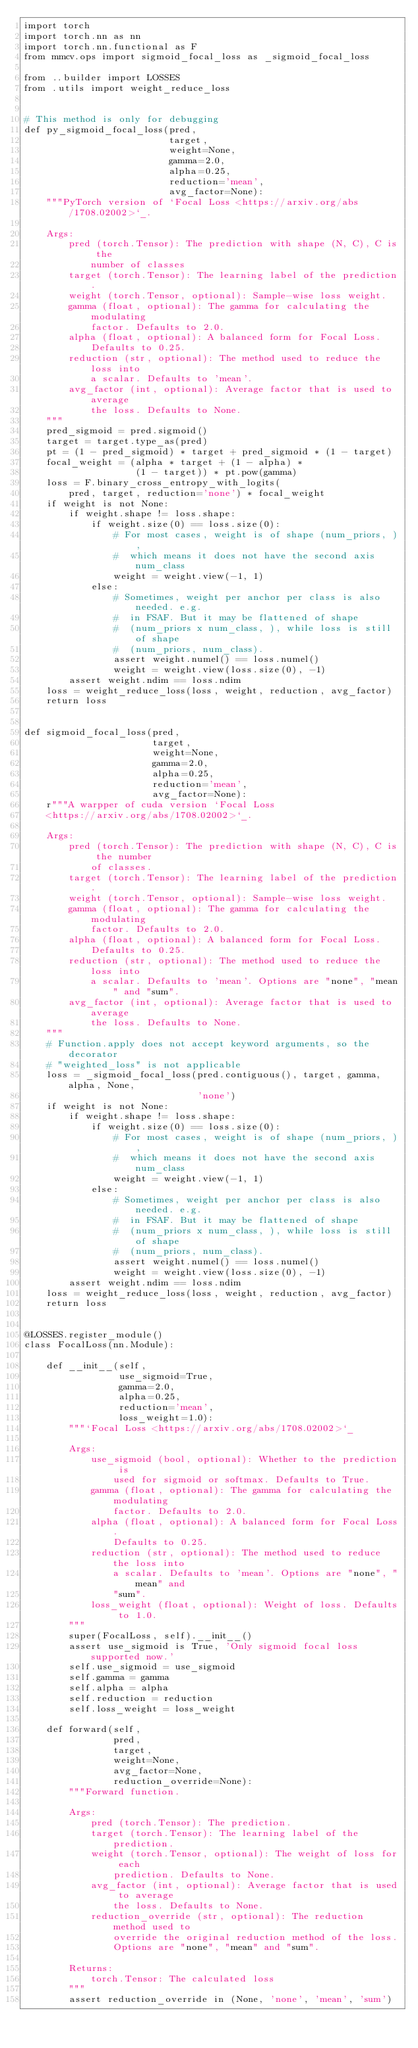<code> <loc_0><loc_0><loc_500><loc_500><_Python_>import torch
import torch.nn as nn
import torch.nn.functional as F
from mmcv.ops import sigmoid_focal_loss as _sigmoid_focal_loss

from ..builder import LOSSES
from .utils import weight_reduce_loss


# This method is only for debugging
def py_sigmoid_focal_loss(pred,
                          target,
                          weight=None,
                          gamma=2.0,
                          alpha=0.25,
                          reduction='mean',
                          avg_factor=None):
    """PyTorch version of `Focal Loss <https://arxiv.org/abs/1708.02002>`_.

    Args:
        pred (torch.Tensor): The prediction with shape (N, C), C is the
            number of classes
        target (torch.Tensor): The learning label of the prediction.
        weight (torch.Tensor, optional): Sample-wise loss weight.
        gamma (float, optional): The gamma for calculating the modulating
            factor. Defaults to 2.0.
        alpha (float, optional): A balanced form for Focal Loss.
            Defaults to 0.25.
        reduction (str, optional): The method used to reduce the loss into
            a scalar. Defaults to 'mean'.
        avg_factor (int, optional): Average factor that is used to average
            the loss. Defaults to None.
    """
    pred_sigmoid = pred.sigmoid()
    target = target.type_as(pred)
    pt = (1 - pred_sigmoid) * target + pred_sigmoid * (1 - target)
    focal_weight = (alpha * target + (1 - alpha) *
                    (1 - target)) * pt.pow(gamma)
    loss = F.binary_cross_entropy_with_logits(
        pred, target, reduction='none') * focal_weight
    if weight is not None:
        if weight.shape != loss.shape:
            if weight.size(0) == loss.size(0):
                # For most cases, weight is of shape (num_priors, ),
                #  which means it does not have the second axis num_class
                weight = weight.view(-1, 1)
            else:
                # Sometimes, weight per anchor per class is also needed. e.g.
                #  in FSAF. But it may be flattened of shape
                #  (num_priors x num_class, ), while loss is still of shape
                #  (num_priors, num_class).
                assert weight.numel() == loss.numel()
                weight = weight.view(loss.size(0), -1)
        assert weight.ndim == loss.ndim
    loss = weight_reduce_loss(loss, weight, reduction, avg_factor)
    return loss


def sigmoid_focal_loss(pred,
                       target,
                       weight=None,
                       gamma=2.0,
                       alpha=0.25,
                       reduction='mean',
                       avg_factor=None):
    r"""A warpper of cuda version `Focal Loss
    <https://arxiv.org/abs/1708.02002>`_.

    Args:
        pred (torch.Tensor): The prediction with shape (N, C), C is the number
            of classes.
        target (torch.Tensor): The learning label of the prediction.
        weight (torch.Tensor, optional): Sample-wise loss weight.
        gamma (float, optional): The gamma for calculating the modulating
            factor. Defaults to 2.0.
        alpha (float, optional): A balanced form for Focal Loss.
            Defaults to 0.25.
        reduction (str, optional): The method used to reduce the loss into
            a scalar. Defaults to 'mean'. Options are "none", "mean" and "sum".
        avg_factor (int, optional): Average factor that is used to average
            the loss. Defaults to None.
    """
    # Function.apply does not accept keyword arguments, so the decorator
    # "weighted_loss" is not applicable
    loss = _sigmoid_focal_loss(pred.contiguous(), target, gamma, alpha, None,
                               'none')
    if weight is not None:
        if weight.shape != loss.shape:
            if weight.size(0) == loss.size(0):
                # For most cases, weight is of shape (num_priors, ),
                #  which means it does not have the second axis num_class
                weight = weight.view(-1, 1)
            else:
                # Sometimes, weight per anchor per class is also needed. e.g.
                #  in FSAF. But it may be flattened of shape
                #  (num_priors x num_class, ), while loss is still of shape
                #  (num_priors, num_class).
                assert weight.numel() == loss.numel()
                weight = weight.view(loss.size(0), -1)
        assert weight.ndim == loss.ndim
    loss = weight_reduce_loss(loss, weight, reduction, avg_factor)
    return loss


@LOSSES.register_module()
class FocalLoss(nn.Module):

    def __init__(self,
                 use_sigmoid=True,
                 gamma=2.0,
                 alpha=0.25,
                 reduction='mean',
                 loss_weight=1.0):
        """`Focal Loss <https://arxiv.org/abs/1708.02002>`_

        Args:
            use_sigmoid (bool, optional): Whether to the prediction is
                used for sigmoid or softmax. Defaults to True.
            gamma (float, optional): The gamma for calculating the modulating
                factor. Defaults to 2.0.
            alpha (float, optional): A balanced form for Focal Loss.
                Defaults to 0.25.
            reduction (str, optional): The method used to reduce the loss into
                a scalar. Defaults to 'mean'. Options are "none", "mean" and
                "sum".
            loss_weight (float, optional): Weight of loss. Defaults to 1.0.
        """
        super(FocalLoss, self).__init__()
        assert use_sigmoid is True, 'Only sigmoid focal loss supported now.'
        self.use_sigmoid = use_sigmoid
        self.gamma = gamma
        self.alpha = alpha
        self.reduction = reduction
        self.loss_weight = loss_weight

    def forward(self,
                pred,
                target,
                weight=None,
                avg_factor=None,
                reduction_override=None):
        """Forward function.

        Args:
            pred (torch.Tensor): The prediction.
            target (torch.Tensor): The learning label of the prediction.
            weight (torch.Tensor, optional): The weight of loss for each
                prediction. Defaults to None.
            avg_factor (int, optional): Average factor that is used to average
                the loss. Defaults to None.
            reduction_override (str, optional): The reduction method used to
                override the original reduction method of the loss.
                Options are "none", "mean" and "sum".

        Returns:
            torch.Tensor: The calculated loss
        """
        assert reduction_override in (None, 'none', 'mean', 'sum')</code> 